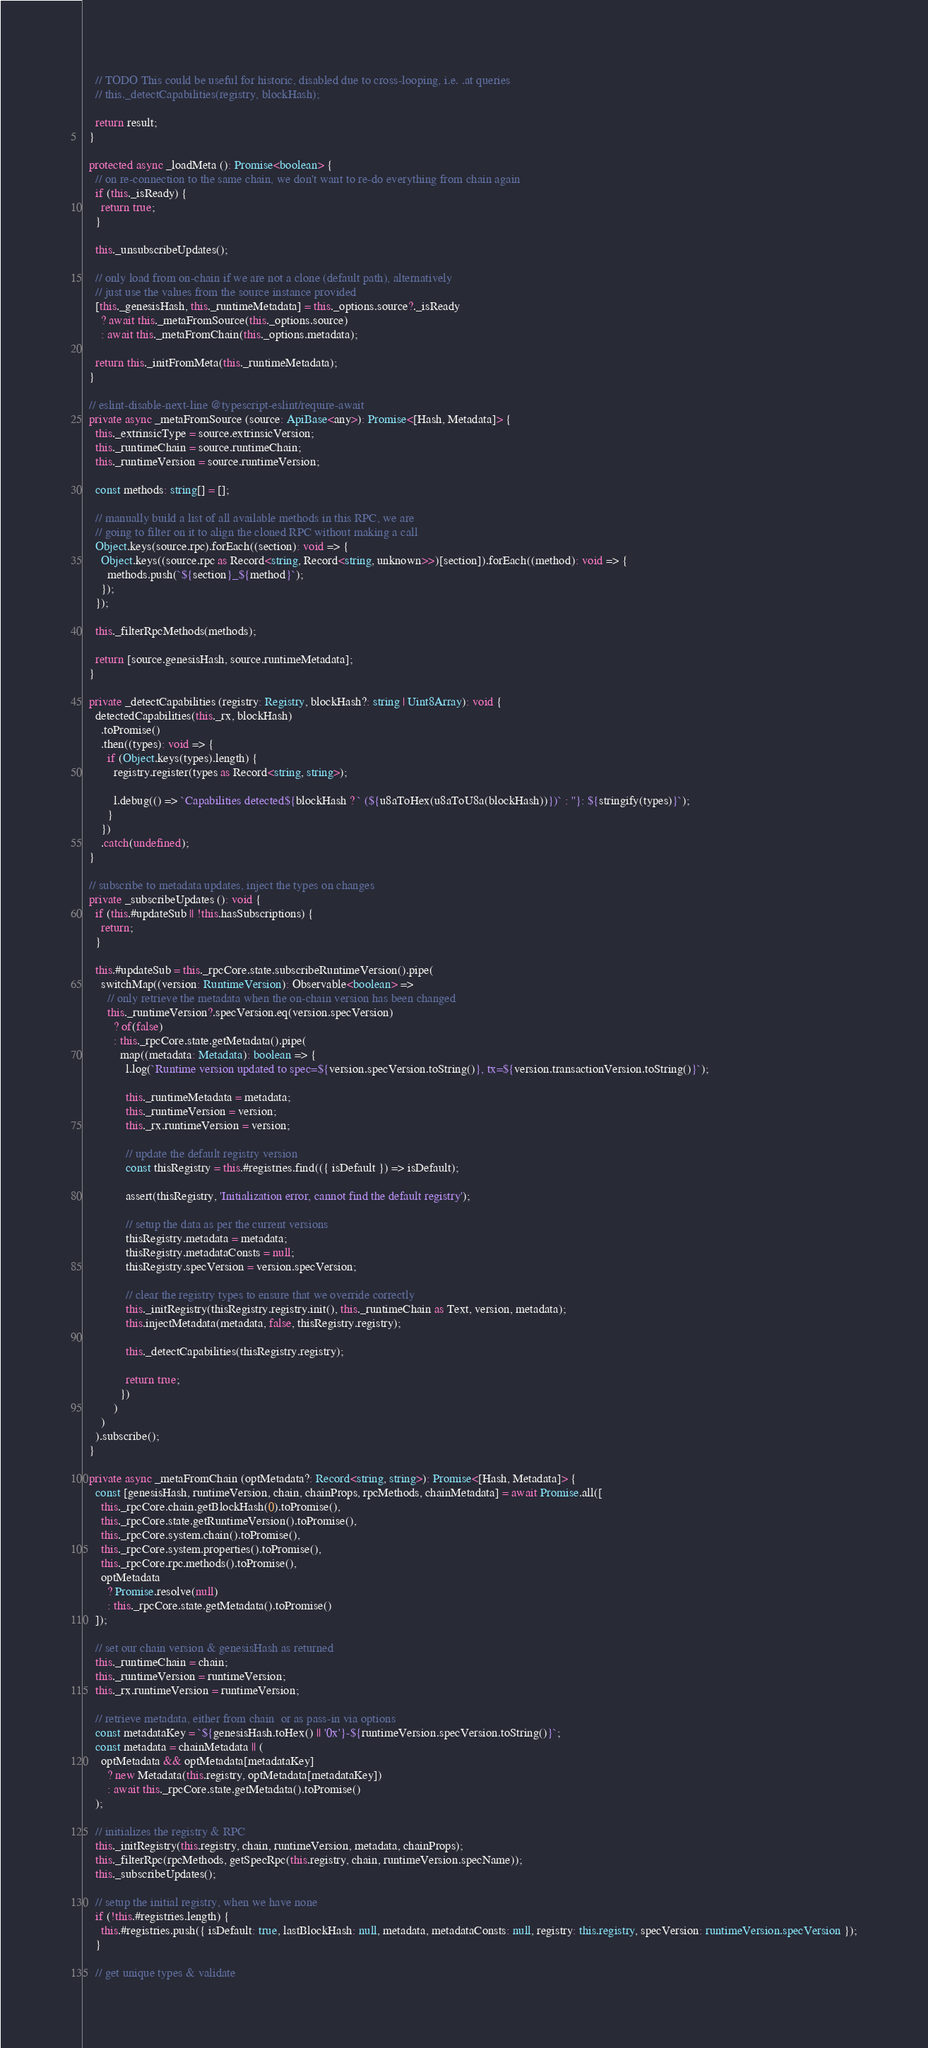Convert code to text. <code><loc_0><loc_0><loc_500><loc_500><_TypeScript_>
    // TODO This could be useful for historic, disabled due to cross-looping, i.e. .at queries
    // this._detectCapabilities(registry, blockHash);

    return result;
  }

  protected async _loadMeta (): Promise<boolean> {
    // on re-connection to the same chain, we don't want to re-do everything from chain again
    if (this._isReady) {
      return true;
    }

    this._unsubscribeUpdates();

    // only load from on-chain if we are not a clone (default path), alternatively
    // just use the values from the source instance provided
    [this._genesisHash, this._runtimeMetadata] = this._options.source?._isReady
      ? await this._metaFromSource(this._options.source)
      : await this._metaFromChain(this._options.metadata);

    return this._initFromMeta(this._runtimeMetadata);
  }

  // eslint-disable-next-line @typescript-eslint/require-await
  private async _metaFromSource (source: ApiBase<any>): Promise<[Hash, Metadata]> {
    this._extrinsicType = source.extrinsicVersion;
    this._runtimeChain = source.runtimeChain;
    this._runtimeVersion = source.runtimeVersion;

    const methods: string[] = [];

    // manually build a list of all available methods in this RPC, we are
    // going to filter on it to align the cloned RPC without making a call
    Object.keys(source.rpc).forEach((section): void => {
      Object.keys((source.rpc as Record<string, Record<string, unknown>>)[section]).forEach((method): void => {
        methods.push(`${section}_${method}`);
      });
    });

    this._filterRpcMethods(methods);

    return [source.genesisHash, source.runtimeMetadata];
  }

  private _detectCapabilities (registry: Registry, blockHash?: string | Uint8Array): void {
    detectedCapabilities(this._rx, blockHash)
      .toPromise()
      .then((types): void => {
        if (Object.keys(types).length) {
          registry.register(types as Record<string, string>);

          l.debug(() => `Capabilities detected${blockHash ? ` (${u8aToHex(u8aToU8a(blockHash))})` : ''}: ${stringify(types)}`);
        }
      })
      .catch(undefined);
  }

  // subscribe to metadata updates, inject the types on changes
  private _subscribeUpdates (): void {
    if (this.#updateSub || !this.hasSubscriptions) {
      return;
    }

    this.#updateSub = this._rpcCore.state.subscribeRuntimeVersion().pipe(
      switchMap((version: RuntimeVersion): Observable<boolean> =>
        // only retrieve the metadata when the on-chain version has been changed
        this._runtimeVersion?.specVersion.eq(version.specVersion)
          ? of(false)
          : this._rpcCore.state.getMetadata().pipe(
            map((metadata: Metadata): boolean => {
              l.log(`Runtime version updated to spec=${version.specVersion.toString()}, tx=${version.transactionVersion.toString()}`);

              this._runtimeMetadata = metadata;
              this._runtimeVersion = version;
              this._rx.runtimeVersion = version;

              // update the default registry version
              const thisRegistry = this.#registries.find(({ isDefault }) => isDefault);

              assert(thisRegistry, 'Initialization error, cannot find the default registry');

              // setup the data as per the current versions
              thisRegistry.metadata = metadata;
              thisRegistry.metadataConsts = null;
              thisRegistry.specVersion = version.specVersion;

              // clear the registry types to ensure that we override correctly
              this._initRegistry(thisRegistry.registry.init(), this._runtimeChain as Text, version, metadata);
              this.injectMetadata(metadata, false, thisRegistry.registry);

              this._detectCapabilities(thisRegistry.registry);

              return true;
            })
          )
      )
    ).subscribe();
  }

  private async _metaFromChain (optMetadata?: Record<string, string>): Promise<[Hash, Metadata]> {
    const [genesisHash, runtimeVersion, chain, chainProps, rpcMethods, chainMetadata] = await Promise.all([
      this._rpcCore.chain.getBlockHash(0).toPromise(),
      this._rpcCore.state.getRuntimeVersion().toPromise(),
      this._rpcCore.system.chain().toPromise(),
      this._rpcCore.system.properties().toPromise(),
      this._rpcCore.rpc.methods().toPromise(),
      optMetadata
        ? Promise.resolve(null)
        : this._rpcCore.state.getMetadata().toPromise()
    ]);

    // set our chain version & genesisHash as returned
    this._runtimeChain = chain;
    this._runtimeVersion = runtimeVersion;
    this._rx.runtimeVersion = runtimeVersion;

    // retrieve metadata, either from chain  or as pass-in via options
    const metadataKey = `${genesisHash.toHex() || '0x'}-${runtimeVersion.specVersion.toString()}`;
    const metadata = chainMetadata || (
      optMetadata && optMetadata[metadataKey]
        ? new Metadata(this.registry, optMetadata[metadataKey])
        : await this._rpcCore.state.getMetadata().toPromise()
    );

    // initializes the registry & RPC
    this._initRegistry(this.registry, chain, runtimeVersion, metadata, chainProps);
    this._filterRpc(rpcMethods, getSpecRpc(this.registry, chain, runtimeVersion.specName));
    this._subscribeUpdates();

    // setup the initial registry, when we have none
    if (!this.#registries.length) {
      this.#registries.push({ isDefault: true, lastBlockHash: null, metadata, metadataConsts: null, registry: this.registry, specVersion: runtimeVersion.specVersion });
    }

    // get unique types & validate</code> 